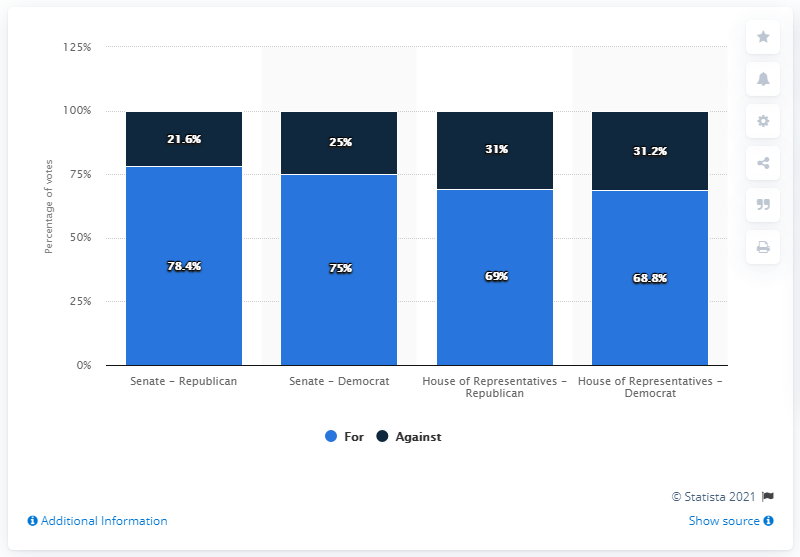Give some essential details in this illustration. The lowest value in the dark blue bar is 21.6. The average of the second and third blue bars is 72. 